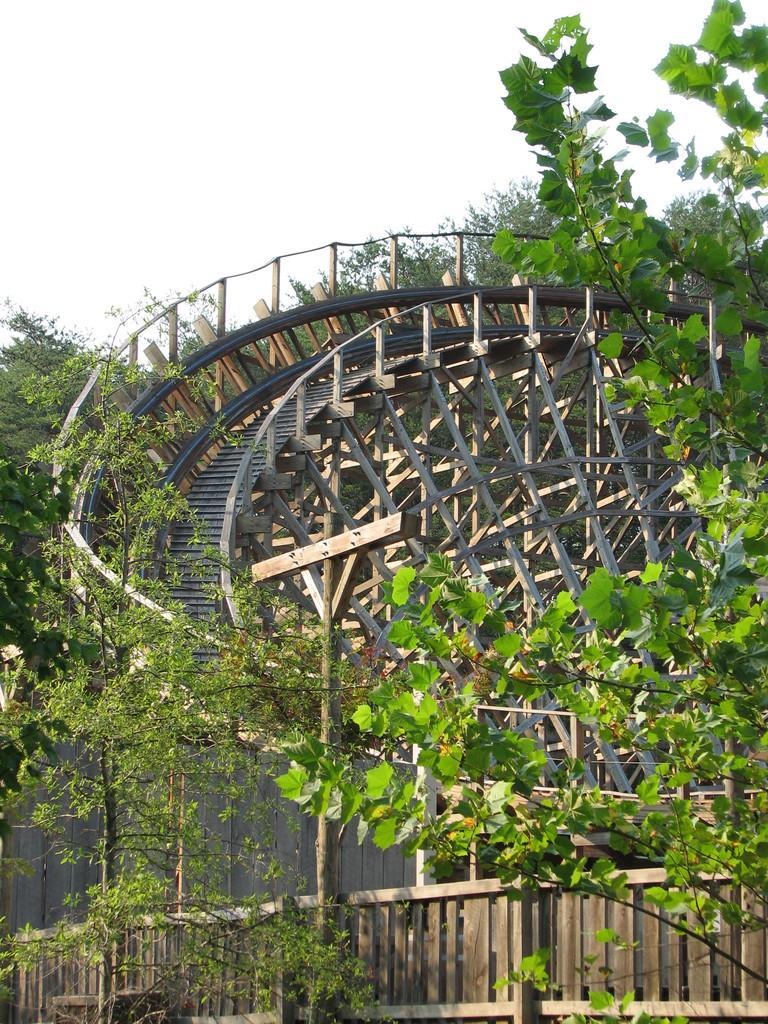Can you describe this image briefly? In this image, this looks like a roller coaster track. These are the trees. At the bottom of the image, I can see the wooden fence. 